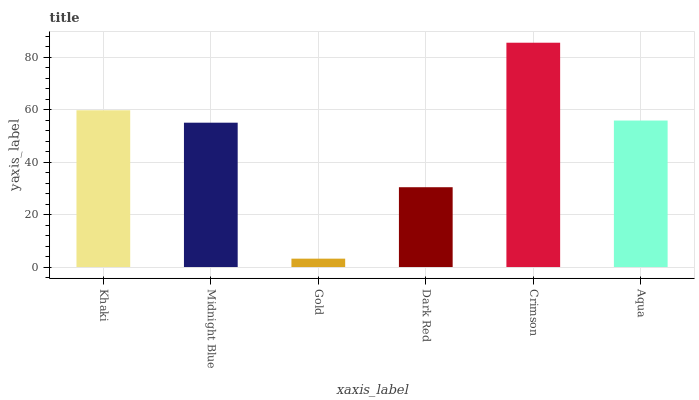Is Gold the minimum?
Answer yes or no. Yes. Is Crimson the maximum?
Answer yes or no. Yes. Is Midnight Blue the minimum?
Answer yes or no. No. Is Midnight Blue the maximum?
Answer yes or no. No. Is Khaki greater than Midnight Blue?
Answer yes or no. Yes. Is Midnight Blue less than Khaki?
Answer yes or no. Yes. Is Midnight Blue greater than Khaki?
Answer yes or no. No. Is Khaki less than Midnight Blue?
Answer yes or no. No. Is Aqua the high median?
Answer yes or no. Yes. Is Midnight Blue the low median?
Answer yes or no. Yes. Is Gold the high median?
Answer yes or no. No. Is Gold the low median?
Answer yes or no. No. 